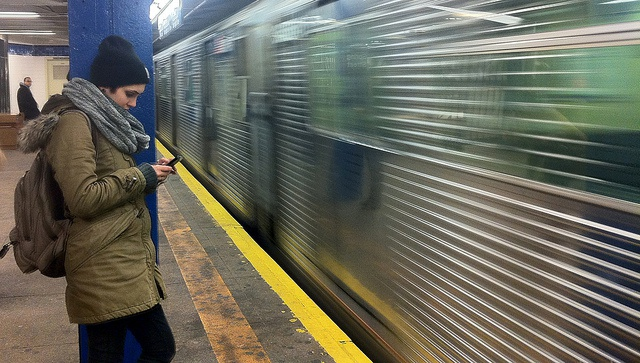Describe the objects in this image and their specific colors. I can see train in gray, black, and darkgray tones, people in gray and black tones, backpack in gray and black tones, people in gray, black, and darkgray tones, and cell phone in gray, black, darkgreen, and maroon tones in this image. 